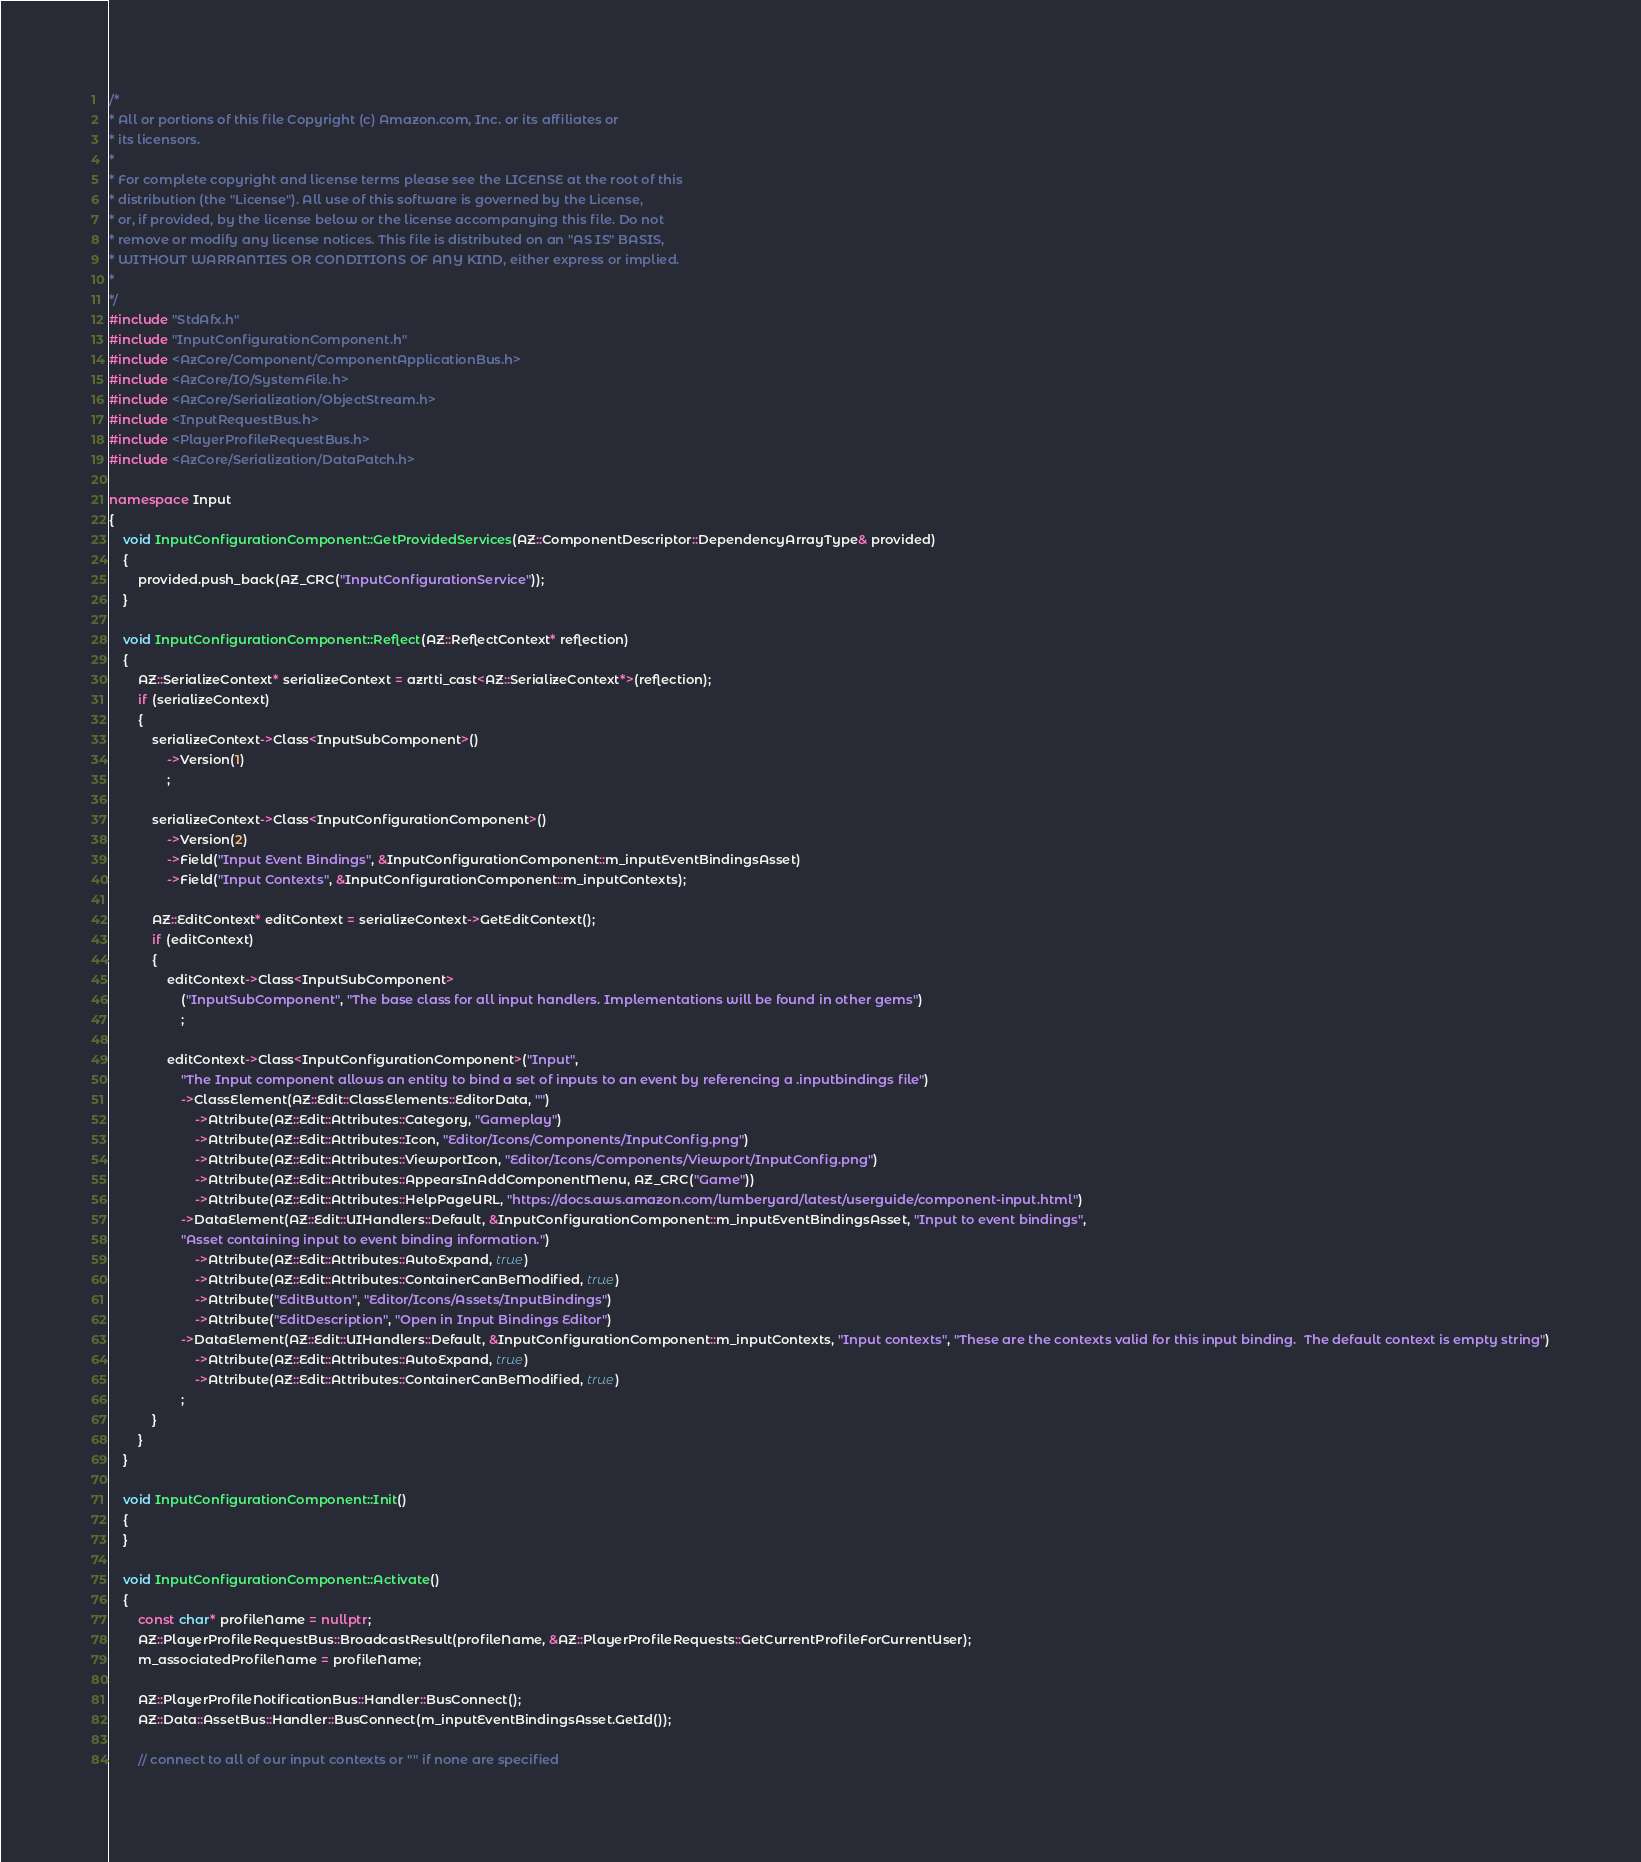<code> <loc_0><loc_0><loc_500><loc_500><_C++_>/*
* All or portions of this file Copyright (c) Amazon.com, Inc. or its affiliates or
* its licensors.
*
* For complete copyright and license terms please see the LICENSE at the root of this
* distribution (the "License"). All use of this software is governed by the License,
* or, if provided, by the license below or the license accompanying this file. Do not
* remove or modify any license notices. This file is distributed on an "AS IS" BASIS,
* WITHOUT WARRANTIES OR CONDITIONS OF ANY KIND, either express or implied.
*
*/
#include "StdAfx.h"
#include "InputConfigurationComponent.h"
#include <AzCore/Component/ComponentApplicationBus.h>
#include <AzCore/IO/SystemFile.h>
#include <AzCore/Serialization/ObjectStream.h>
#include <InputRequestBus.h>
#include <PlayerProfileRequestBus.h>
#include <AzCore/Serialization/DataPatch.h>

namespace Input
{
    void InputConfigurationComponent::GetProvidedServices(AZ::ComponentDescriptor::DependencyArrayType& provided)
    {
        provided.push_back(AZ_CRC("InputConfigurationService"));
    }

    void InputConfigurationComponent::Reflect(AZ::ReflectContext* reflection)
    {
        AZ::SerializeContext* serializeContext = azrtti_cast<AZ::SerializeContext*>(reflection);
        if (serializeContext)
        {
            serializeContext->Class<InputSubComponent>()
                ->Version(1)
                ;

            serializeContext->Class<InputConfigurationComponent>()
                ->Version(2)
                ->Field("Input Event Bindings", &InputConfigurationComponent::m_inputEventBindingsAsset)
                ->Field("Input Contexts", &InputConfigurationComponent::m_inputContexts);

            AZ::EditContext* editContext = serializeContext->GetEditContext();
            if (editContext)
            {
                editContext->Class<InputSubComponent>
                    ("InputSubComponent", "The base class for all input handlers. Implementations will be found in other gems")
                    ;

                editContext->Class<InputConfigurationComponent>("Input",
                    "The Input component allows an entity to bind a set of inputs to an event by referencing a .inputbindings file")
                    ->ClassElement(AZ::Edit::ClassElements::EditorData, "")
                        ->Attribute(AZ::Edit::Attributes::Category, "Gameplay")
                        ->Attribute(AZ::Edit::Attributes::Icon, "Editor/Icons/Components/InputConfig.png")
                        ->Attribute(AZ::Edit::Attributes::ViewportIcon, "Editor/Icons/Components/Viewport/InputConfig.png")
                        ->Attribute(AZ::Edit::Attributes::AppearsInAddComponentMenu, AZ_CRC("Game"))
                        ->Attribute(AZ::Edit::Attributes::HelpPageURL, "https://docs.aws.amazon.com/lumberyard/latest/userguide/component-input.html")
                    ->DataElement(AZ::Edit::UIHandlers::Default, &InputConfigurationComponent::m_inputEventBindingsAsset, "Input to event bindings",
                    "Asset containing input to event binding information.")
                        ->Attribute(AZ::Edit::Attributes::AutoExpand, true)
                        ->Attribute(AZ::Edit::Attributes::ContainerCanBeModified, true)
                        ->Attribute("EditButton", "Editor/Icons/Assets/InputBindings")
                        ->Attribute("EditDescription", "Open in Input Bindings Editor")
                    ->DataElement(AZ::Edit::UIHandlers::Default, &InputConfigurationComponent::m_inputContexts, "Input contexts", "These are the contexts valid for this input binding.  The default context is empty string")
                        ->Attribute(AZ::Edit::Attributes::AutoExpand, true)
                        ->Attribute(AZ::Edit::Attributes::ContainerCanBeModified, true)
                    ;
            }
        }
    }

    void InputConfigurationComponent::Init()
    {
    }

    void InputConfigurationComponent::Activate()
    {
        const char* profileName = nullptr;
        AZ::PlayerProfileRequestBus::BroadcastResult(profileName, &AZ::PlayerProfileRequests::GetCurrentProfileForCurrentUser);
        m_associatedProfileName = profileName;

        AZ::PlayerProfileNotificationBus::Handler::BusConnect();
        AZ::Data::AssetBus::Handler::BusConnect(m_inputEventBindingsAsset.GetId());

        // connect to all of our input contexts or "" if none are specified</code> 